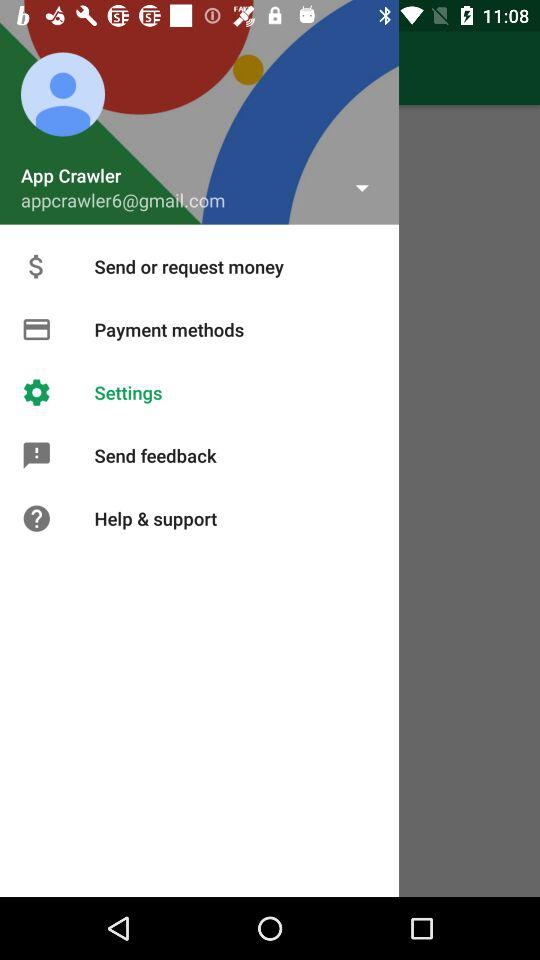What is the email address? The email address is appcrawler6@gmail.com. 